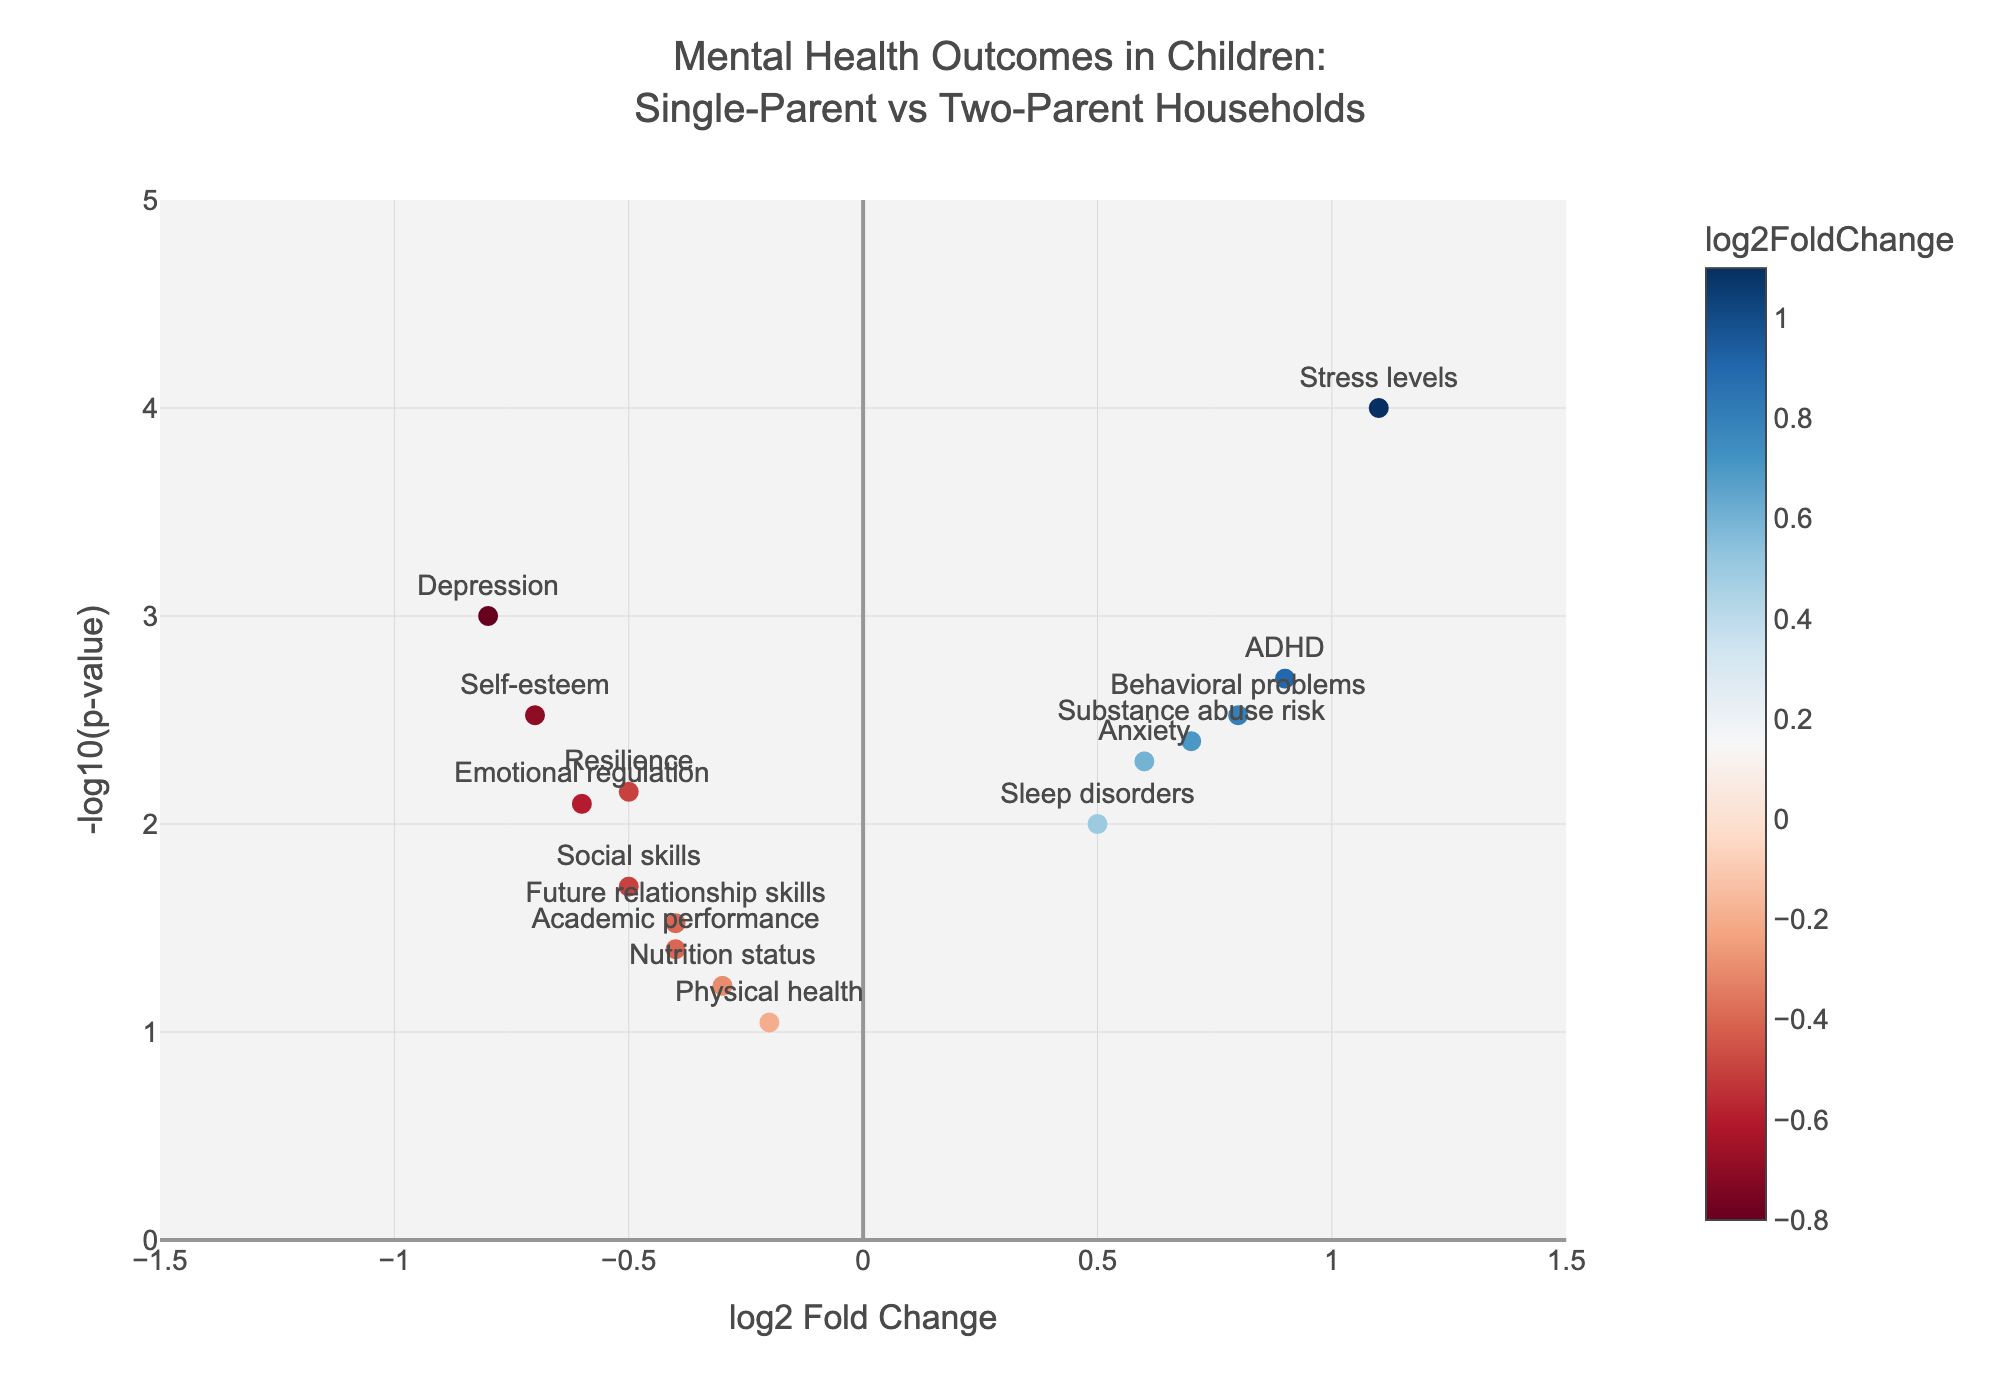What is the title of the figure? The title of the figure is usually displayed at the top of the chart. For this figure, it states "Mental Health Outcomes in Children:<br>Single-Parent vs Two-Parent Households."
Answer: Mental Health Outcomes in Children: Single-Parent vs Two-Parent Households How many mental health outcomes are represented in the figure? Each mental health outcome corresponds to a unique marker on the plot, and by counting the number of markers, we can determine there are 15 outcomes.
Answer: 15 Which mental health outcome has the highest log2 Fold Change value? By examining the x-axis, the mental health outcome with the highest log2 Fold Change is the marker farthest to the right. That outcome is "Stress levels" with a value of 1.1.
Answer: Stress levels Which outcome has the lowest p-value? The p-value is represented by the y-axis as -log10(p-value). The outcome with the highest position on the y-axis and therefore the lowest p-value is "Stress levels."
Answer: Stress levels Which mental health outcome shows a decrease in single-parent households compared to two-parent households? Outcomes to the left of the zero on the x-axis (negative log2 Fold Change) indicate a decrease in single-parent households. Looking at those points, "Depression," "Self-esteem," and "Emotional regulation" show decreases.
Answer: Depression, Self-esteem, Emotional regulation What is the log2 Fold Change value and p-value for ADHD? For specific markers, we refer to the hovertext displayed on the plot. The hovertext for "ADHD" shows log2 Fold Change: 0.9 and p-value: 0.002.
Answer: log2 Fold Change: 0.9, p-value: 0.002 Which outcomes are statistically significant (commonly defined as p-value < 0.05) and indicate worse conditions in single-parent households? Outcomes to the right of the zero on the x-axis with markers above the significance threshold on the y-axis are "Anxiety," "ADHD," "Behavioral problems," "Substance abuse risk," and "Stress levels."
Answer: Anxiety, ADHD, Behavioral problems, Substance abuse risk, Stress levels What do the colors of the markers represent? The color of the markers represents the value of the log2 Fold Change, as indicated by the color legend (with a colorscale ranging from blue to red).
Answer: log2 Fold Change How does "Social skills" compare in terms of log2 Fold Change and statistical significance to "Academic performance"? "Social skills" has a log2 Fold Change of -0.5 and p-value of 0.02, while "Academic performance" has a log2 Fold Change of -0.4 and a p-value of 0.04. "Social skills" has a more negative log2 Fold Change and a lower p-value, indicating a slightly higher significance.
Answer: Social skills: higher negative log2 Fold Change, more significant What does a negative log2 Fold Change indicate in this context? A negative log2 Fold Change indicates a worse mental health outcome for children in single-parent households compared to those in two-parent households. This is derived because the log2 Fold Change measures the ratio of outcomes between these groups, and negative values show a reduction in single-parent households.
Answer: Worse outcome in single-parent households 